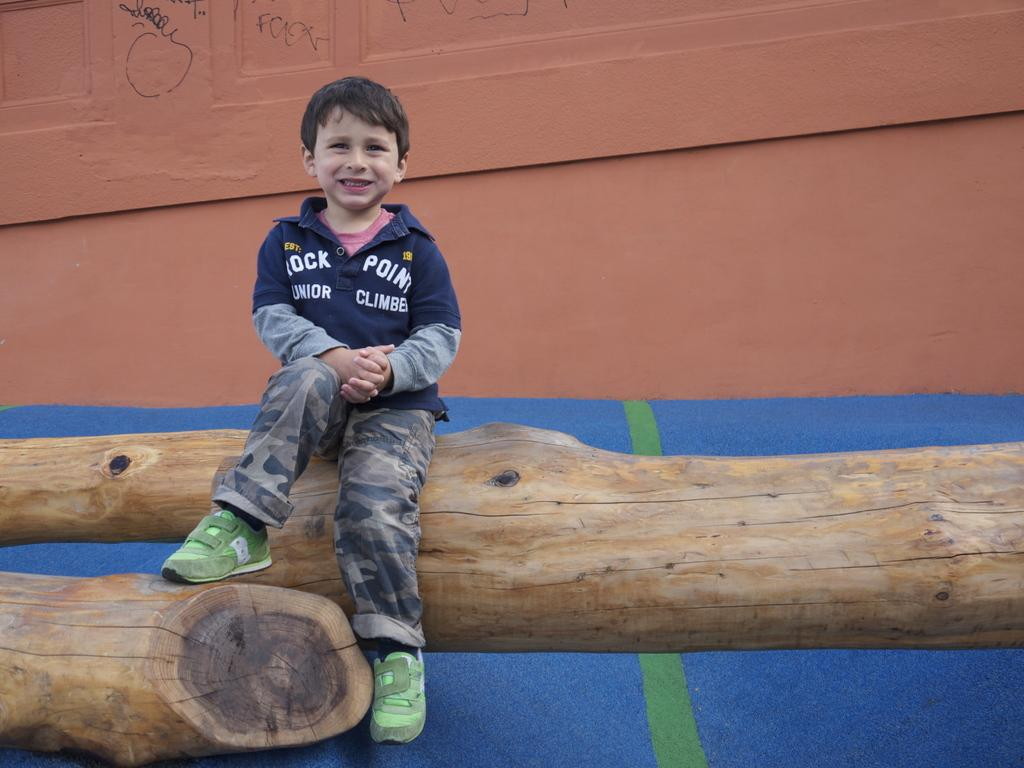Who is the main subject in the image? There is a boy in the image. What is the boy sitting on? The boy is seated on tree bark. What can be seen in the background of the image? There is a wall in the image. What are the colors of the wall? The wall is brown and blue in color. What is the boy wearing? The boy is wearing a blue t-shirt and green shoes. What type of milk is the boy drinking in the image? There is no milk present in the image; the boy is seated on tree bark and wearing a blue t-shirt and green shoes. 